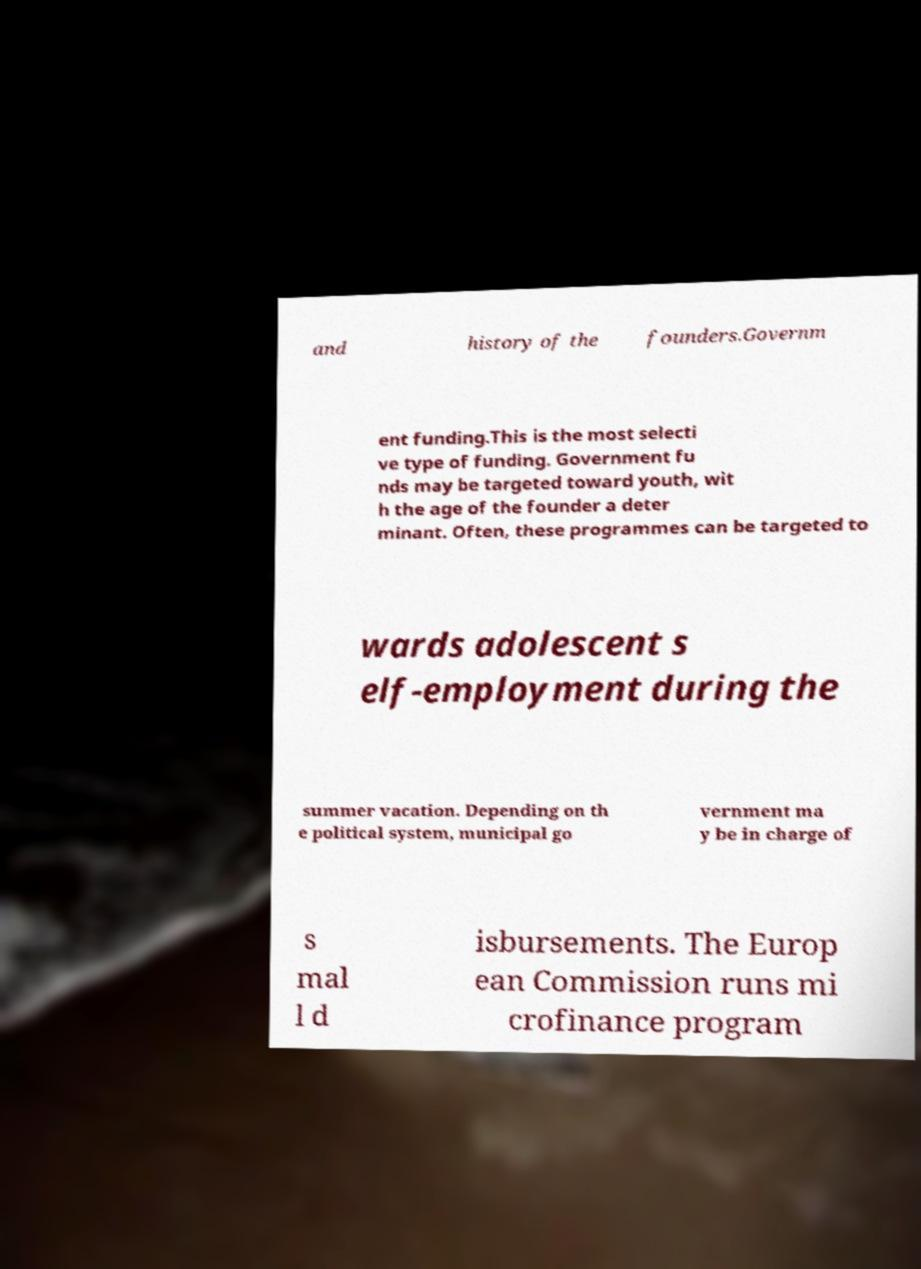Please read and relay the text visible in this image. What does it say? and history of the founders.Governm ent funding.This is the most selecti ve type of funding. Government fu nds may be targeted toward youth, wit h the age of the founder a deter minant. Often, these programmes can be targeted to wards adolescent s elf-employment during the summer vacation. Depending on th e political system, municipal go vernment ma y be in charge of s mal l d isbursements. The Europ ean Commission runs mi crofinance program 